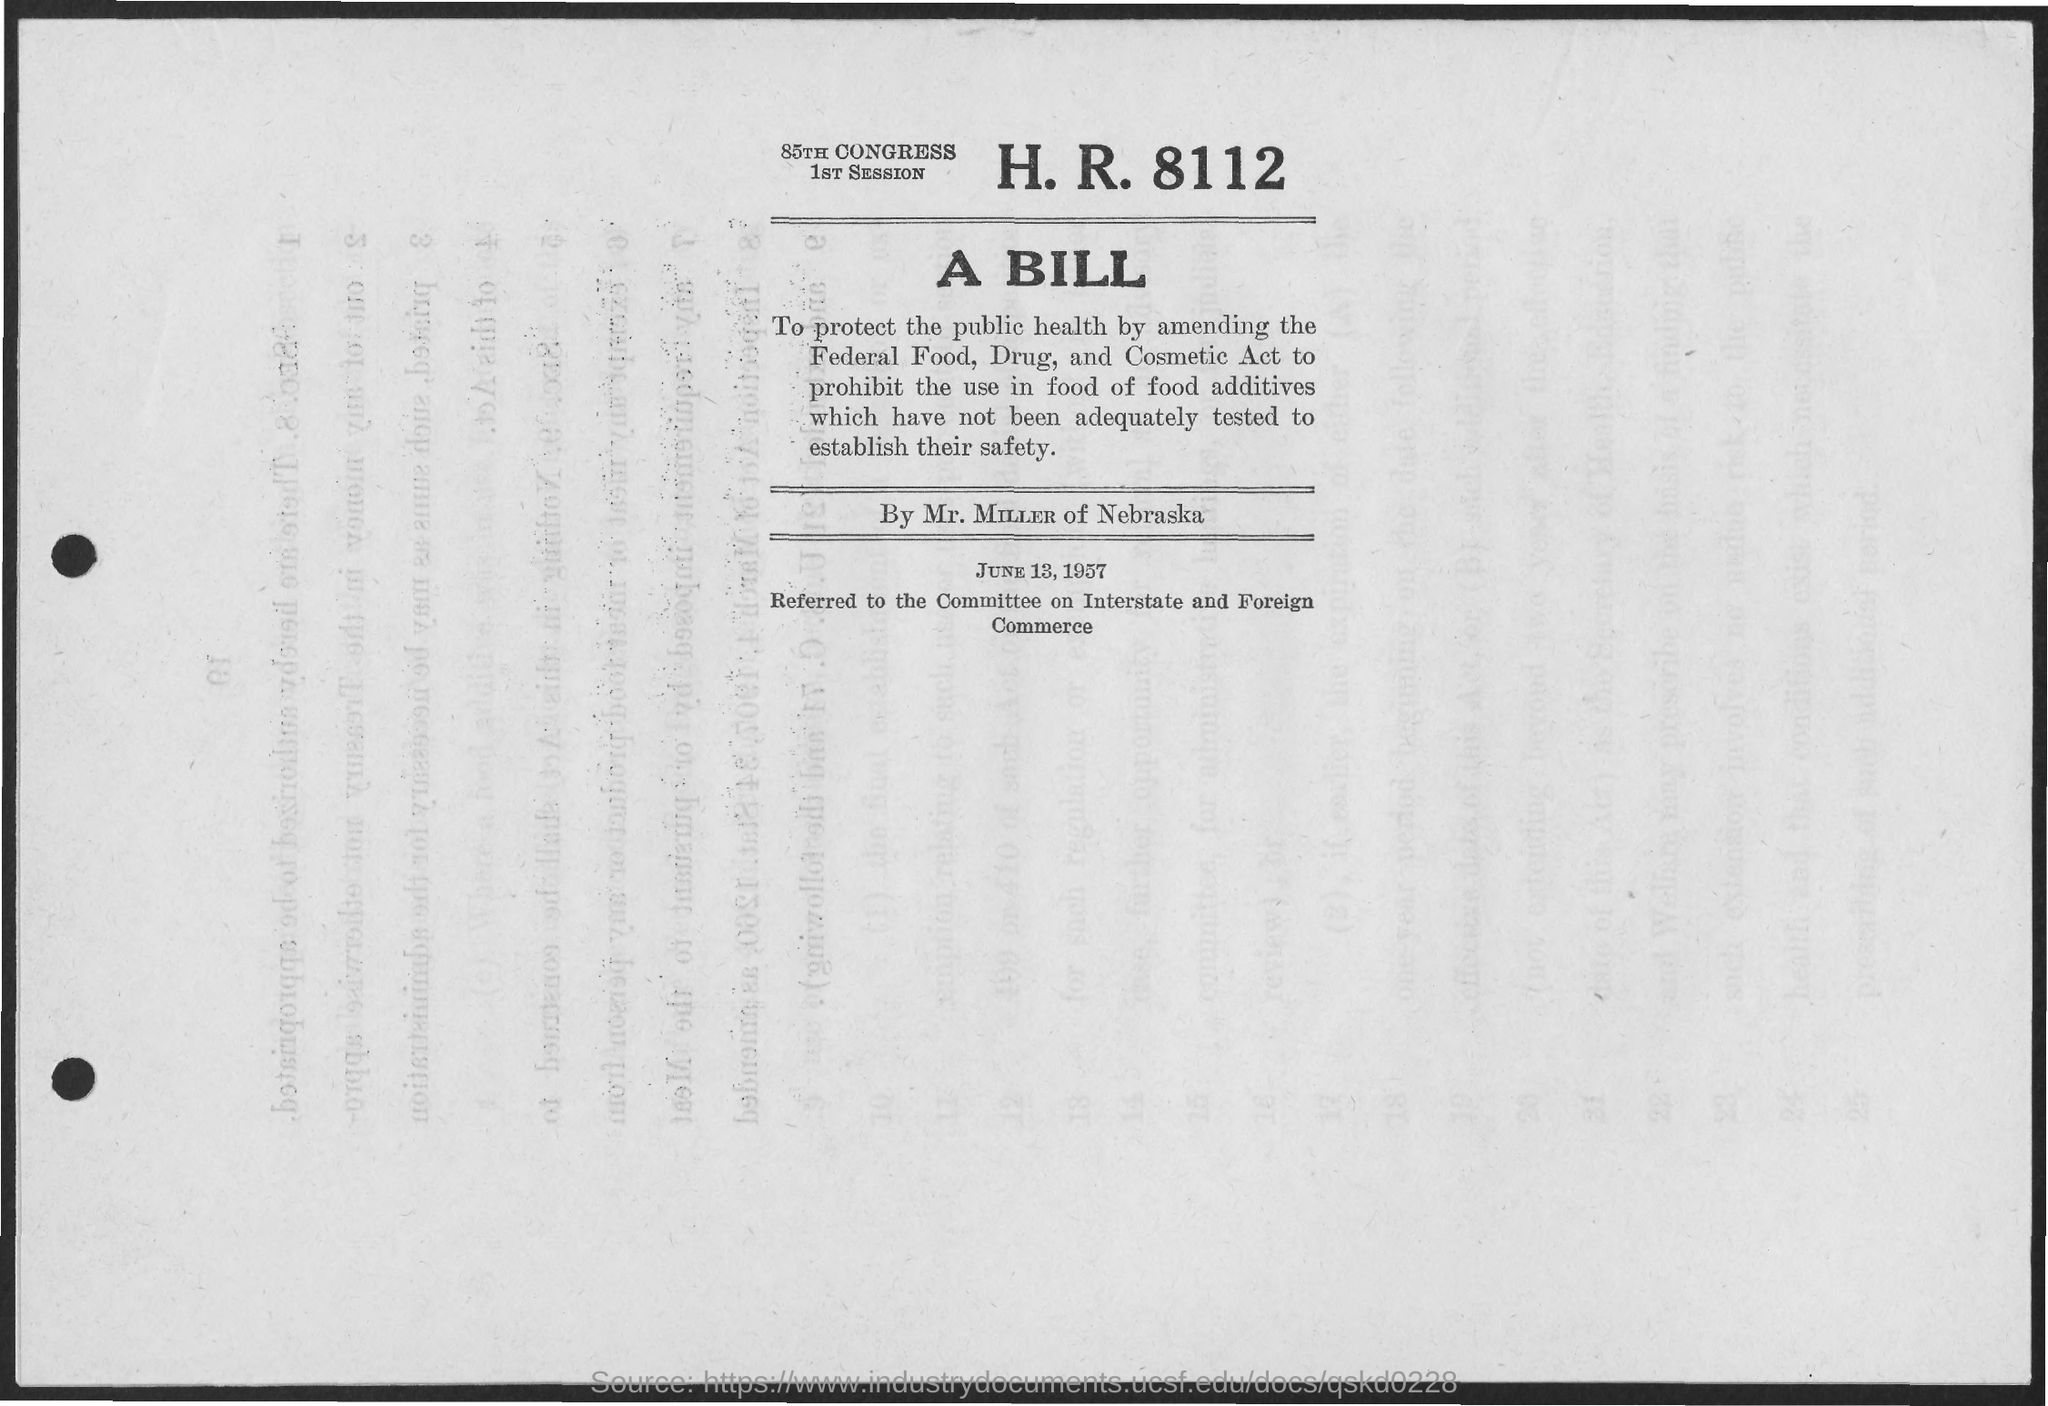When is the document dated?
Provide a succinct answer. JUNE 13, 1957. 